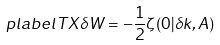<formula> <loc_0><loc_0><loc_500><loc_500>\ p l a b e l { T X } \delta W = - \frac { 1 } { 2 } \zeta ( 0 | \delta k , A )</formula> 